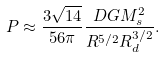Convert formula to latex. <formula><loc_0><loc_0><loc_500><loc_500>P \approx \frac { 3 \sqrt { 1 4 } } { 5 6 \pi } \frac { D G M _ { s } ^ { 2 } } { R ^ { 5 / 2 } R _ { d } ^ { 3 / 2 } } .</formula> 